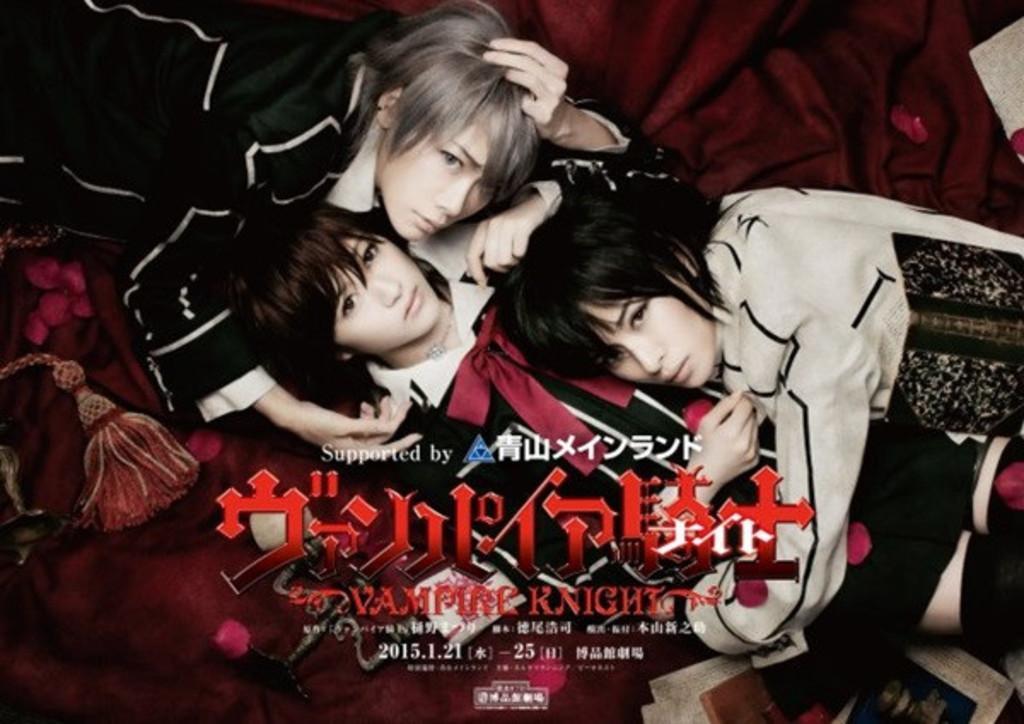How would you summarize this image in a sentence or two? This is an edited image in which there are persons lying and there is some text written on it. 